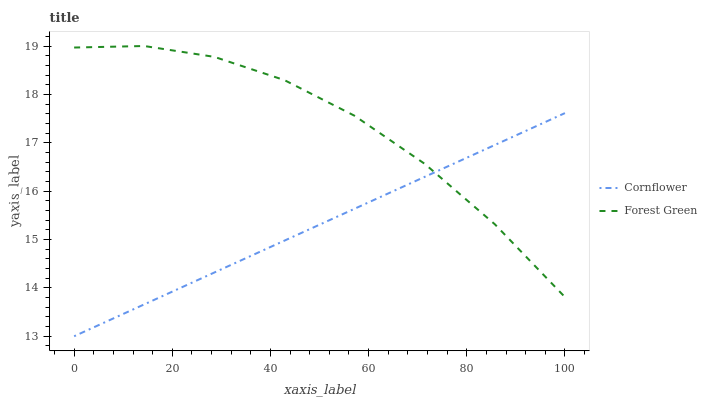Does Cornflower have the minimum area under the curve?
Answer yes or no. Yes. Does Forest Green have the minimum area under the curve?
Answer yes or no. No. Is Forest Green the roughest?
Answer yes or no. Yes. Is Forest Green the smoothest?
Answer yes or no. No. Does Forest Green have the lowest value?
Answer yes or no. No. 